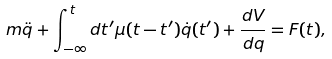<formula> <loc_0><loc_0><loc_500><loc_500>m \ddot { q } + \int _ { - \infty } ^ { t } d t ^ { \prime } \mu ( t - t ^ { \prime } ) \dot { q } ( t ^ { \prime } ) + \frac { d V } { d q } = F ( t ) ,</formula> 